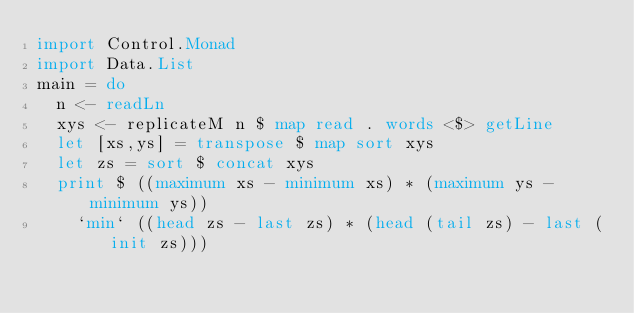<code> <loc_0><loc_0><loc_500><loc_500><_Haskell_>import Control.Monad
import Data.List
main = do
  n <- readLn
  xys <- replicateM n $ map read . words <$> getLine
  let [xs,ys] = transpose $ map sort xys
  let zs = sort $ concat xys
  print $ ((maximum xs - minimum xs) * (maximum ys - minimum ys))
    `min` ((head zs - last zs) * (head (tail zs) - last (init zs)))</code> 